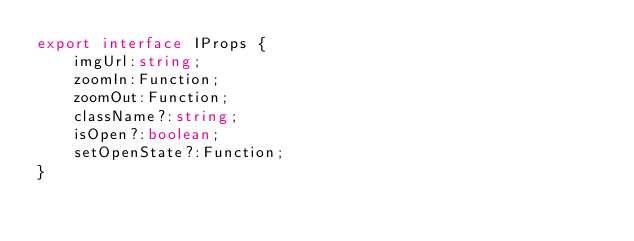<code> <loc_0><loc_0><loc_500><loc_500><_TypeScript_>export interface IProps {
    imgUrl:string;
    zoomIn:Function;
    zoomOut:Function;
    className?:string;
    isOpen?:boolean;
    setOpenState?:Function;
}</code> 